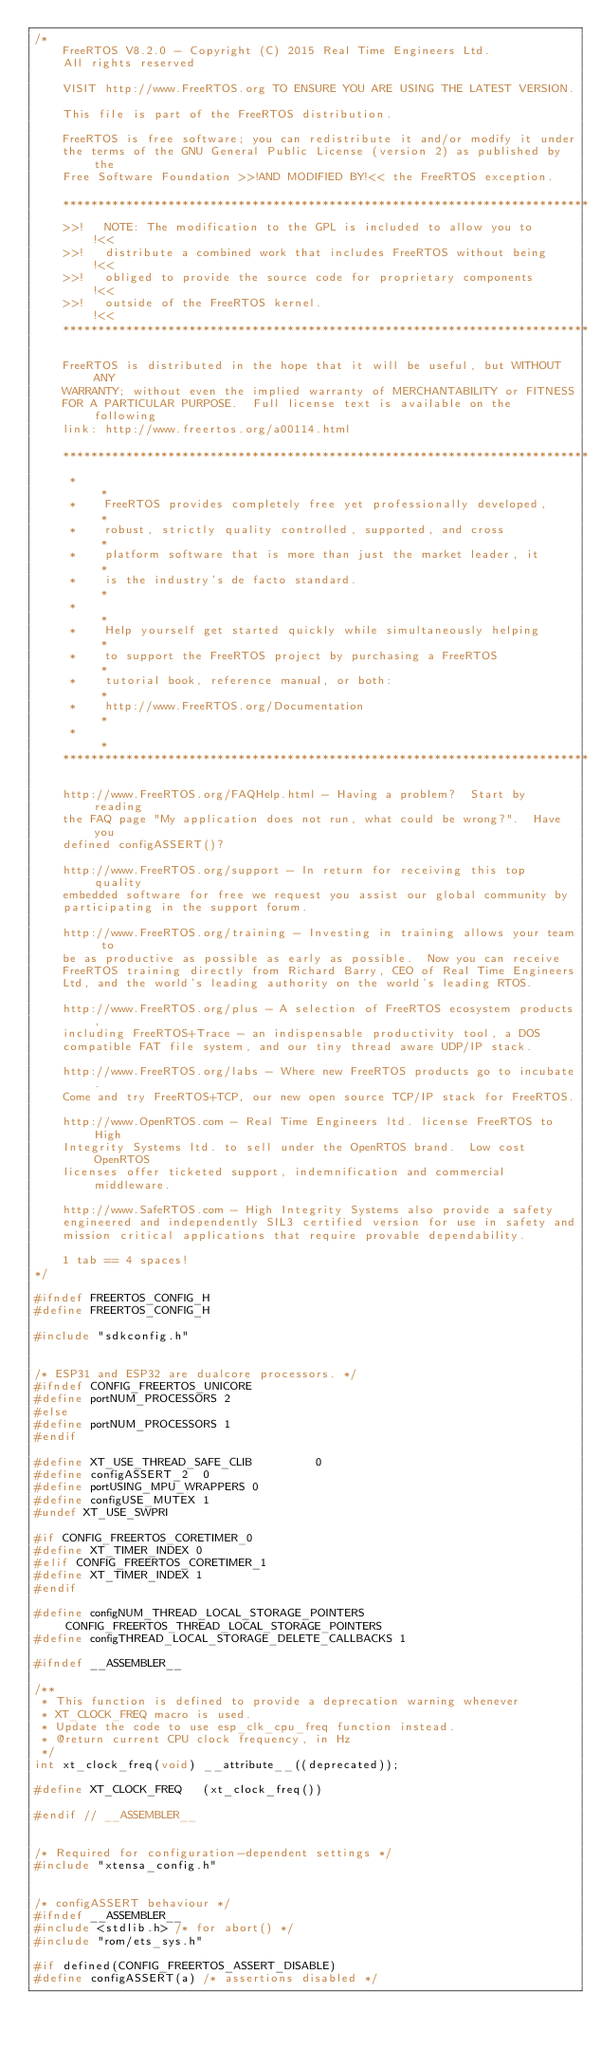<code> <loc_0><loc_0><loc_500><loc_500><_C_>/*
    FreeRTOS V8.2.0 - Copyright (C) 2015 Real Time Engineers Ltd.
    All rights reserved

    VISIT http://www.FreeRTOS.org TO ENSURE YOU ARE USING THE LATEST VERSION.

    This file is part of the FreeRTOS distribution.

    FreeRTOS is free software; you can redistribute it and/or modify it under
    the terms of the GNU General Public License (version 2) as published by the
    Free Software Foundation >>!AND MODIFIED BY!<< the FreeRTOS exception.

	***************************************************************************
    >>!   NOTE: The modification to the GPL is included to allow you to     !<<
    >>!   distribute a combined work that includes FreeRTOS without being   !<<
    >>!   obliged to provide the source code for proprietary components     !<<
    >>!   outside of the FreeRTOS kernel.                                   !<<
	***************************************************************************

    FreeRTOS is distributed in the hope that it will be useful, but WITHOUT ANY
    WARRANTY; without even the implied warranty of MERCHANTABILITY or FITNESS
    FOR A PARTICULAR PURPOSE.  Full license text is available on the following
    link: http://www.freertos.org/a00114.html

    ***************************************************************************
     *                                                                       *
     *    FreeRTOS provides completely free yet professionally developed,    *
     *    robust, strictly quality controlled, supported, and cross          *
     *    platform software that is more than just the market leader, it     *
     *    is the industry's de facto standard.                               *
     *                                                                       *
     *    Help yourself get started quickly while simultaneously helping     *
     *    to support the FreeRTOS project by purchasing a FreeRTOS           *
     *    tutorial book, reference manual, or both:                          *
     *    http://www.FreeRTOS.org/Documentation                              *
     *                                                                       *
    ***************************************************************************

    http://www.FreeRTOS.org/FAQHelp.html - Having a problem?  Start by reading
	the FAQ page "My application does not run, what could be wrong?".  Have you
	defined configASSERT()?

	http://www.FreeRTOS.org/support - In return for receiving this top quality
	embedded software for free we request you assist our global community by
	participating in the support forum.

	http://www.FreeRTOS.org/training - Investing in training allows your team to
	be as productive as possible as early as possible.  Now you can receive
	FreeRTOS training directly from Richard Barry, CEO of Real Time Engineers
	Ltd, and the world's leading authority on the world's leading RTOS.

    http://www.FreeRTOS.org/plus - A selection of FreeRTOS ecosystem products,
    including FreeRTOS+Trace - an indispensable productivity tool, a DOS
    compatible FAT file system, and our tiny thread aware UDP/IP stack.

    http://www.FreeRTOS.org/labs - Where new FreeRTOS products go to incubate.
    Come and try FreeRTOS+TCP, our new open source TCP/IP stack for FreeRTOS.

    http://www.OpenRTOS.com - Real Time Engineers ltd. license FreeRTOS to High
    Integrity Systems ltd. to sell under the OpenRTOS brand.  Low cost OpenRTOS
    licenses offer ticketed support, indemnification and commercial middleware.

    http://www.SafeRTOS.com - High Integrity Systems also provide a safety
    engineered and independently SIL3 certified version for use in safety and
    mission critical applications that require provable dependability.

    1 tab == 4 spaces!
*/

#ifndef FREERTOS_CONFIG_H
#define FREERTOS_CONFIG_H

#include "sdkconfig.h"


/* ESP31 and ESP32 are dualcore processors. */
#ifndef CONFIG_FREERTOS_UNICORE
#define portNUM_PROCESSORS 2
#else 
#define portNUM_PROCESSORS 1
#endif

#define XT_USE_THREAD_SAFE_CLIB			0
#define configASSERT_2	0
#define portUSING_MPU_WRAPPERS 0
#define configUSE_MUTEX 1
#undef XT_USE_SWPRI

#if CONFIG_FREERTOS_CORETIMER_0
#define XT_TIMER_INDEX 0
#elif CONFIG_FREERTOS_CORETIMER_1
#define XT_TIMER_INDEX 1
#endif

#define configNUM_THREAD_LOCAL_STORAGE_POINTERS CONFIG_FREERTOS_THREAD_LOCAL_STORAGE_POINTERS
#define configTHREAD_LOCAL_STORAGE_DELETE_CALLBACKS 1

#ifndef __ASSEMBLER__

/**
 * This function is defined to provide a deprecation warning whenever
 * XT_CLOCK_FREQ macro is used.
 * Update the code to use esp_clk_cpu_freq function instead.
 * @return current CPU clock frequency, in Hz
 */
int xt_clock_freq(void) __attribute__((deprecated));

#define XT_CLOCK_FREQ   (xt_clock_freq())

#endif // __ASSEMBLER__


/* Required for configuration-dependent settings */
#include "xtensa_config.h"


/* configASSERT behaviour */
#ifndef __ASSEMBLER__
#include <stdlib.h> /* for abort() */
#include "rom/ets_sys.h"

#if defined(CONFIG_FREERTOS_ASSERT_DISABLE)
#define configASSERT(a) /* assertions disabled */</code> 